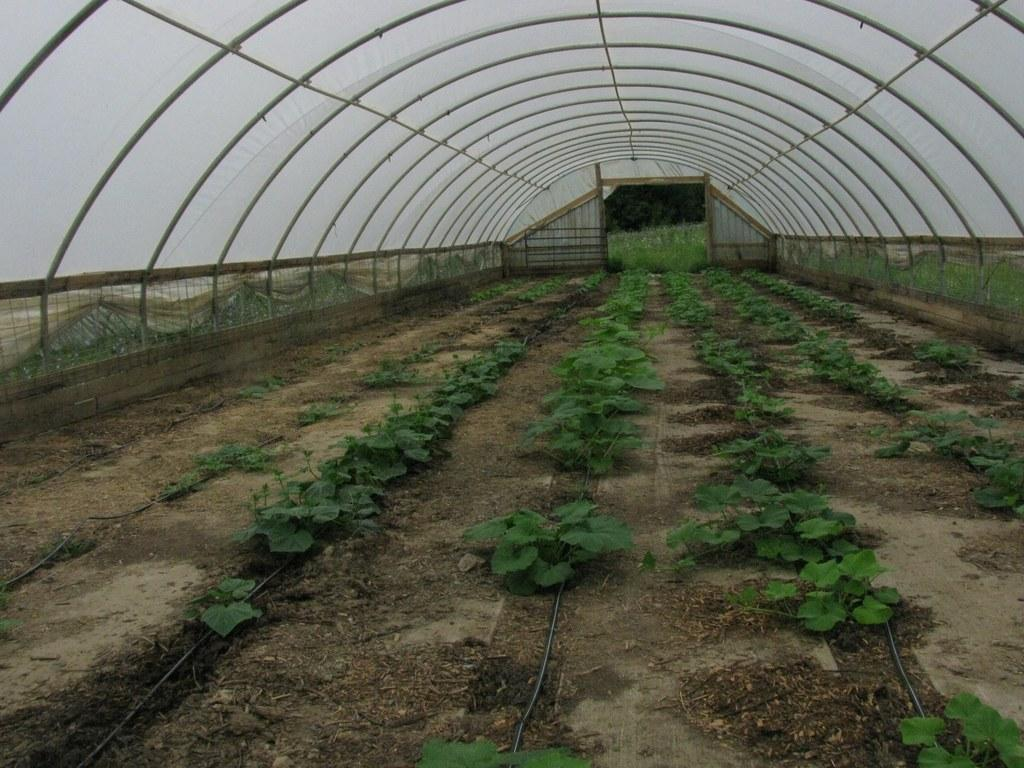What type of plants can be seen in the image? There are green color plants in the image. Can you describe any structures visible in the image? Yes, there is a shed at the top of the image. How does the person in the image show respect to the plants? There is no person present in the image, so it is not possible to determine how they might show respect to the plants. 